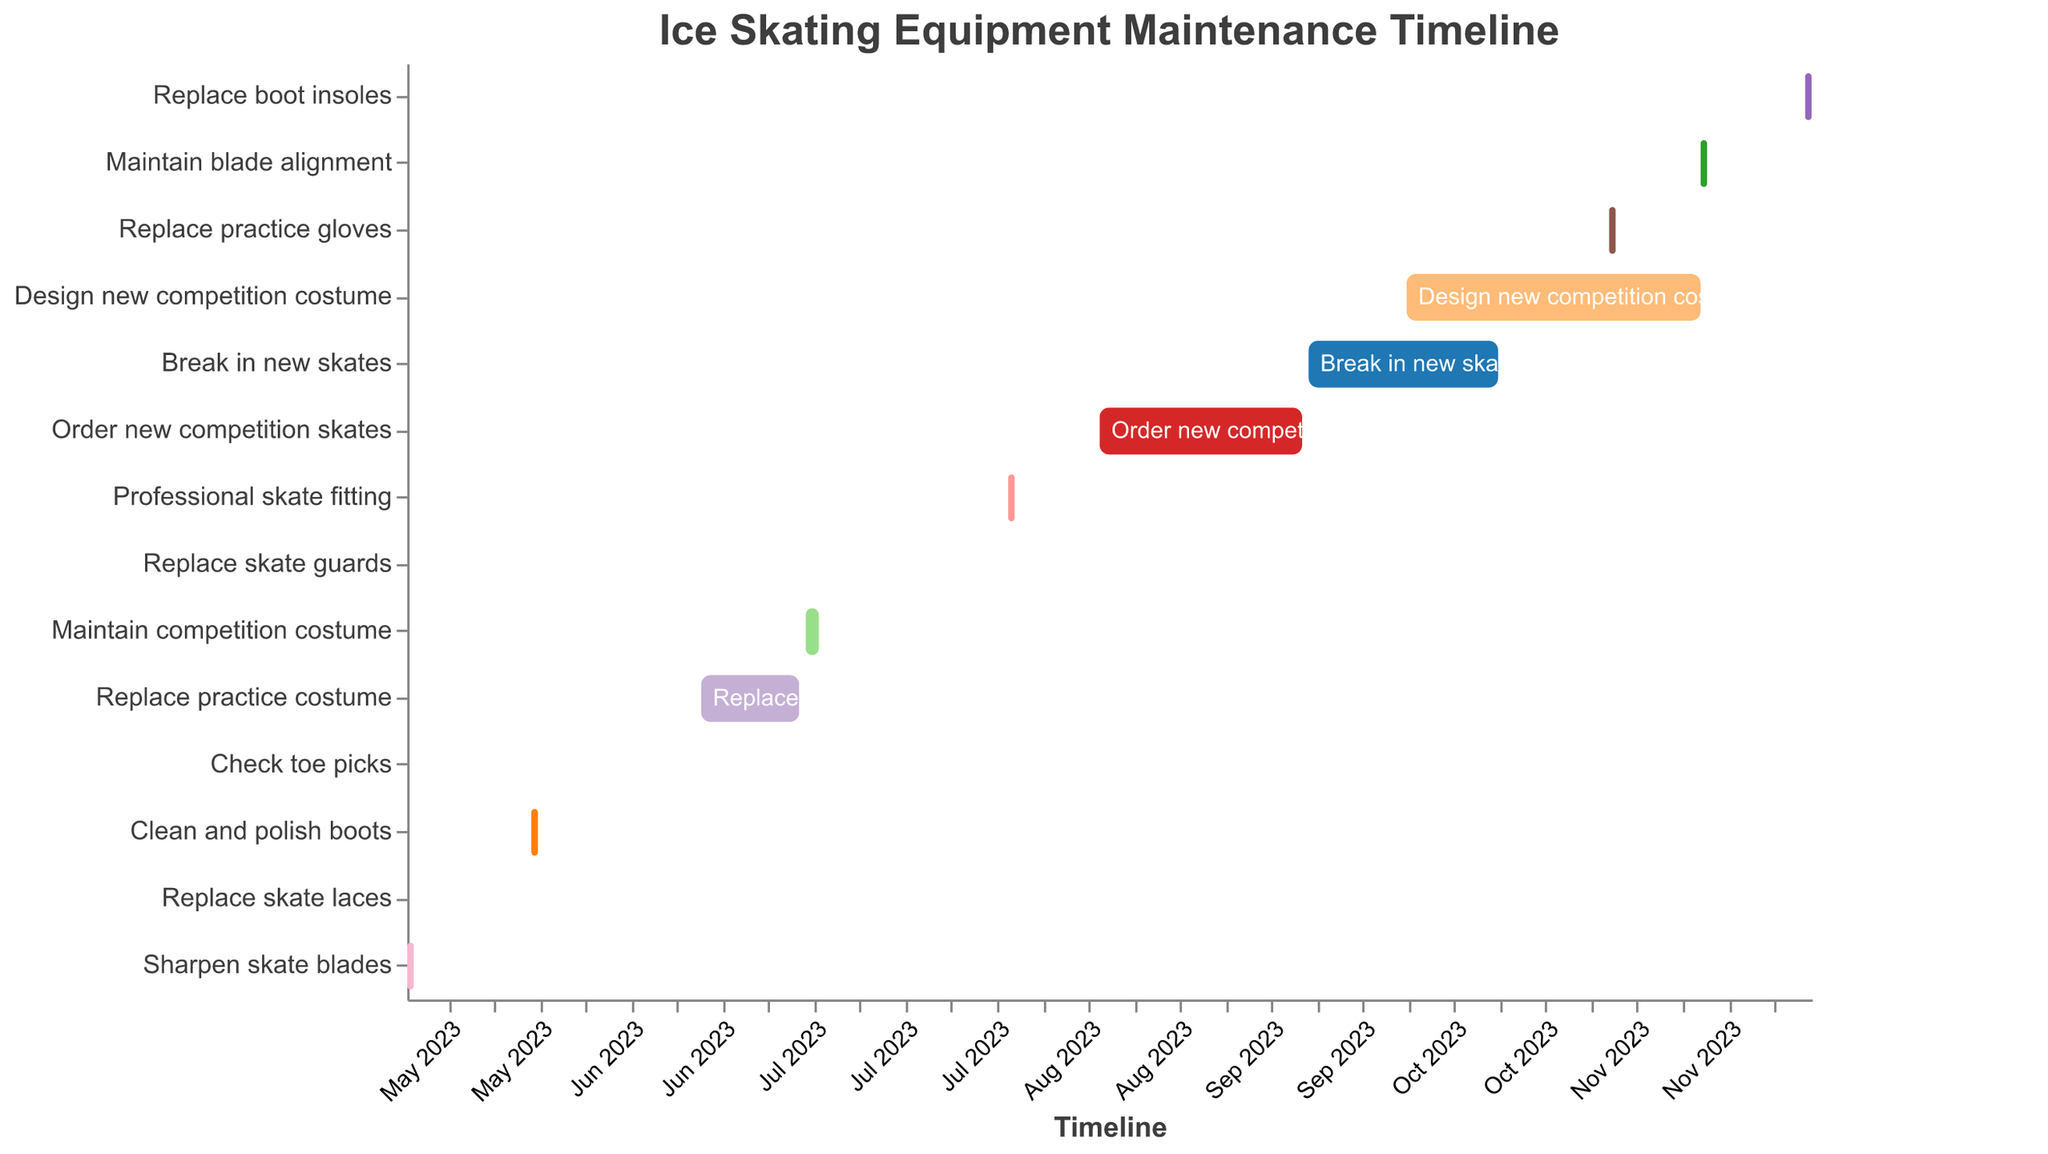When is the task "Clean and polish boots" scheduled to start and end? According to the Gantt chart, the task "Clean and polish boots" starts on May 20, 2023, and ends on May 21, 2023.
Answer: May 20, 2023 to May 21, 2023 What maintenance task is scheduled for November 15, 2023? By referring to the Gantt chart, the task "Maintain blade alignment" is scheduled on November 15, 2023.
Answer: Maintain blade alignment Which task has the longest duration? To determine the task with the longest duration, we look for the largest span between the start and end dates on the Gantt chart. "Design new competition costume" starts on October 1, 2023, and ends on November 15, 2023, giving it a duration of 45 days.
Answer: Design new competition costume Which tasks are scheduled to be completed within a single day? Tasks that start and end on the same date on the Gantt chart are completed within a single day. These tasks are "Replace skate laces," "Check toe picks," and "Replace skate guards."
Answer: Replace skate laces, Check toe picks, Replace skate guards What two tasks are scheduled consecutively without a break in between? To find consecutive tasks with no break, we look for tasks that start immediately after the previous task ends. "Order new competition skates" ends on September 15, 2023, and "Break in new skates" starts on September 16, 2023.
Answer: Order new competition skates and Break in new skates During which month does "Professional skate fitting" occur? By examining the Gantt chart, the "Professional skate fitting" task starts and ends within August 2023.
Answer: August 2023 Compare the durations of "Break in new skates" and "Replace practice costume." Which one is longer? "Break in new skates" is scheduled from September 16, 2023, to October 15, 2023 (30 days), while "Replace practice costume" is scheduled from June 15, 2023, to June 30, 2023 (15 days). Thus, "Break in new skates" is longer.
Answer: Break in new skates How many tasks are scheduled to start in June 2023? By counting the tasks on the Gantt chart that start in June, we see that "Check toe picks" starts on June 1, and "Replace practice costume" starts on June 15. Therefore, 2 tasks start in June 2023.
Answer: 2 Which task happens immediately before "Replace boot insoles"? Looking at the Gantt chart, "Maintain blade alignment" ends on November 16, 2023, which is immediately before "Replace boot insoles" starts on December 1, 2023.
Answer: Maintain blade alignment How many maintenance tasks for costumes are there, and what are their names? The Gantt chart shows tasks involving costumes: "Replace practice costume," "Maintain competition costume," and "Design new competition costume," totaling three tasks.
Answer: 3, Replace practice costume, Maintain competition costume, Design new competition costume 